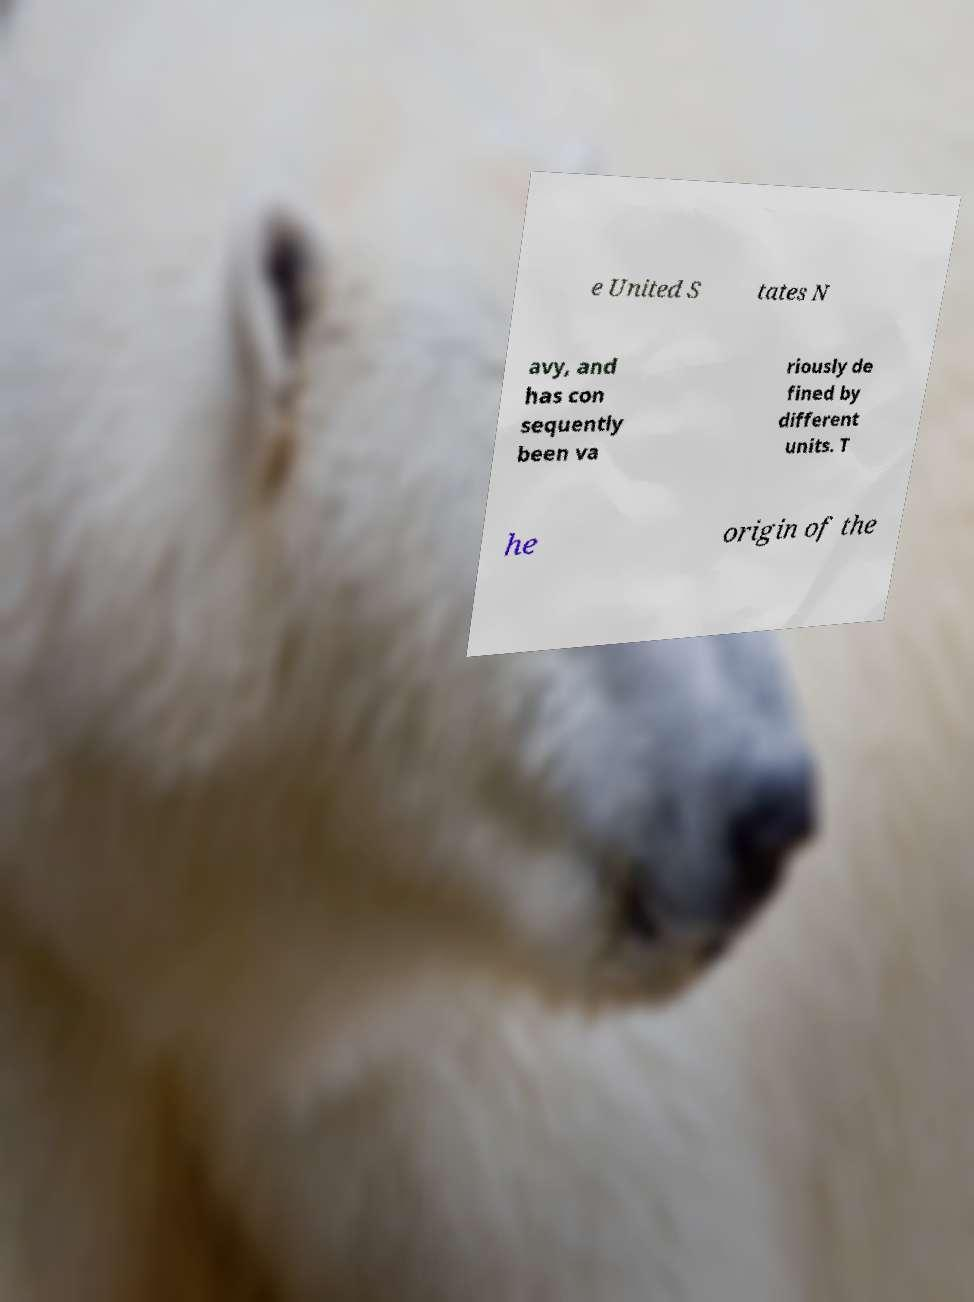I need the written content from this picture converted into text. Can you do that? e United S tates N avy, and has con sequently been va riously de fined by different units. T he origin of the 